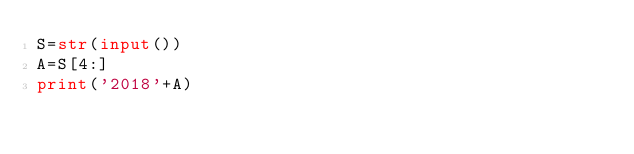<code> <loc_0><loc_0><loc_500><loc_500><_Python_>S=str(input())
A=S[4:]
print('2018'+A)</code> 